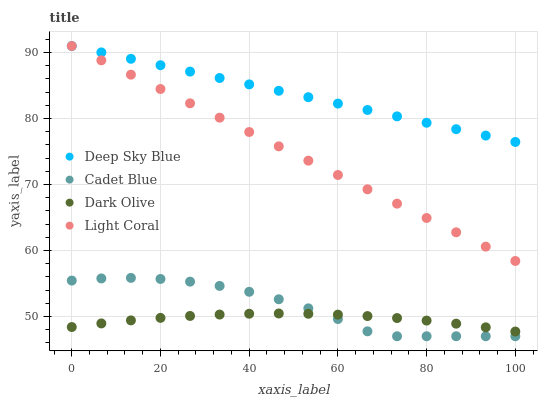Does Dark Olive have the minimum area under the curve?
Answer yes or no. Yes. Does Deep Sky Blue have the maximum area under the curve?
Answer yes or no. Yes. Does Light Coral have the minimum area under the curve?
Answer yes or no. No. Does Light Coral have the maximum area under the curve?
Answer yes or no. No. Is Light Coral the smoothest?
Answer yes or no. Yes. Is Cadet Blue the roughest?
Answer yes or no. Yes. Is Cadet Blue the smoothest?
Answer yes or no. No. Is Light Coral the roughest?
Answer yes or no. No. Does Cadet Blue have the lowest value?
Answer yes or no. Yes. Does Light Coral have the lowest value?
Answer yes or no. No. Does Deep Sky Blue have the highest value?
Answer yes or no. Yes. Does Cadet Blue have the highest value?
Answer yes or no. No. Is Dark Olive less than Deep Sky Blue?
Answer yes or no. Yes. Is Deep Sky Blue greater than Dark Olive?
Answer yes or no. Yes. Does Deep Sky Blue intersect Light Coral?
Answer yes or no. Yes. Is Deep Sky Blue less than Light Coral?
Answer yes or no. No. Is Deep Sky Blue greater than Light Coral?
Answer yes or no. No. Does Dark Olive intersect Deep Sky Blue?
Answer yes or no. No. 